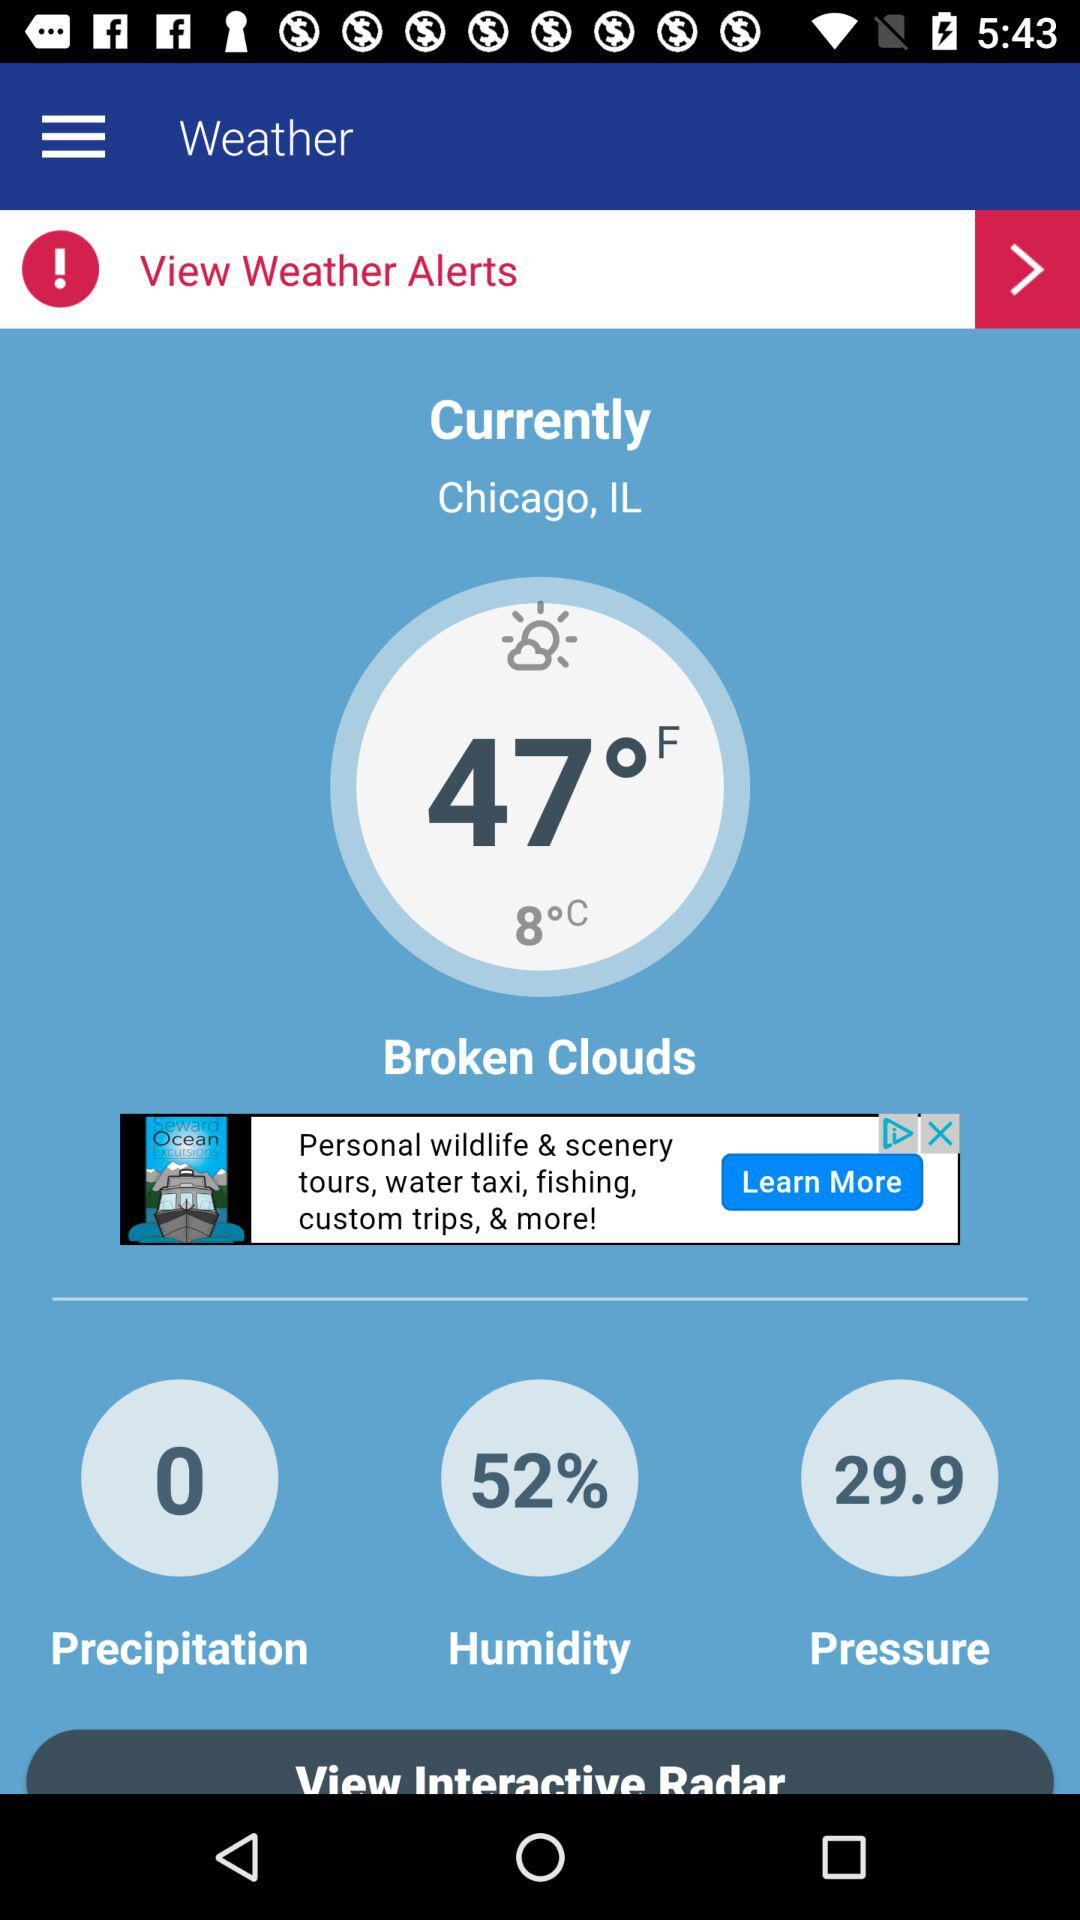What is the location? The location is Chicago, IL. 